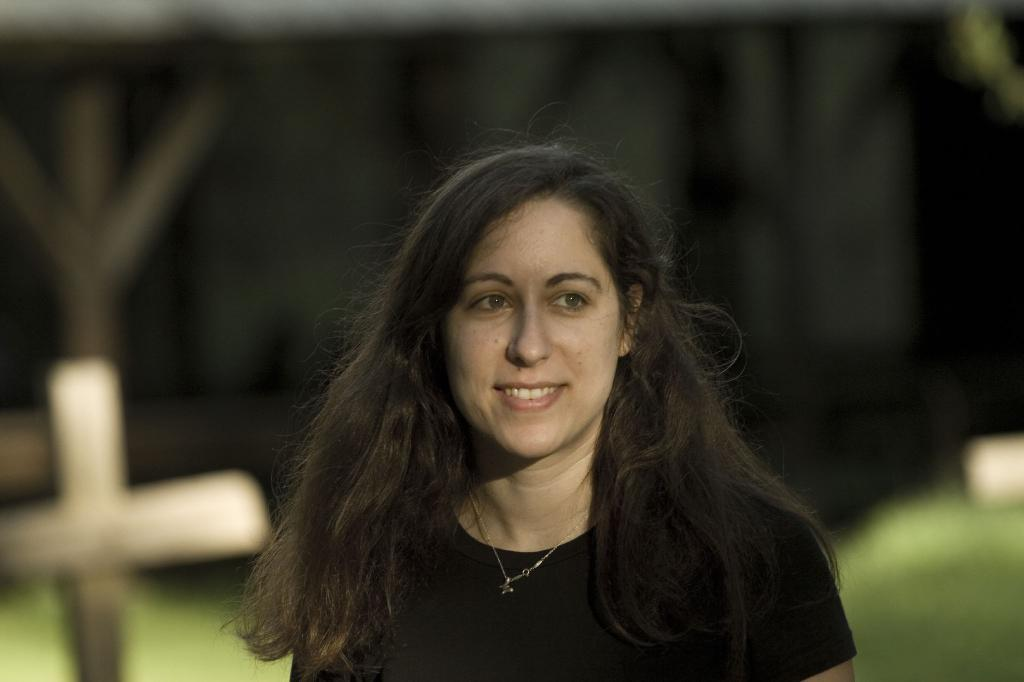Who is present in the image? There is a woman in the image. What is the woman wearing? The woman is wearing clothes and a neck chain. What is the woman's facial expression? The woman is smiling. What symbol can be seen in the image? There is a cross symbol in the image. How would you describe the background of the image? The background of the image is blurred. What type of fuel is being used by the woman in the image? There is no mention of any fuel or vehicle in the image, so it cannot be determined what type of fuel the woman might be using. 